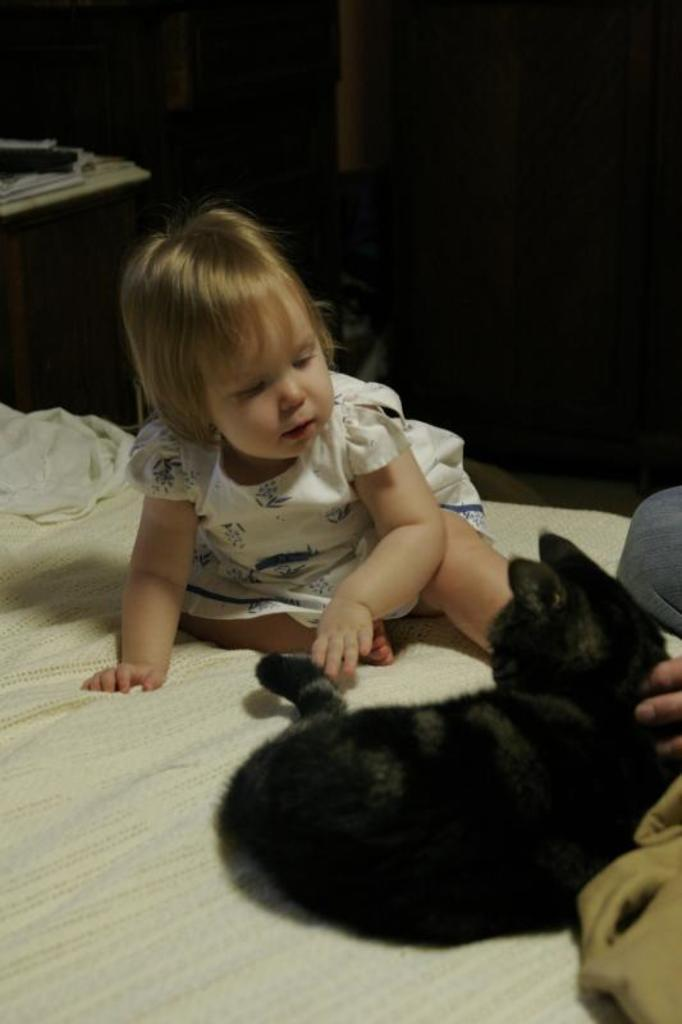What is the kid doing in the image? The kid is sitting on the bed. What is in front of the kid? There is an animal in front of the kid. What can be seen in the background of the image? There is a door in the background of the image. What type of pipes can be seen in the image? There are no pipes present in the image. What authority figure is present in the image? There is no authority figure present in the image. 